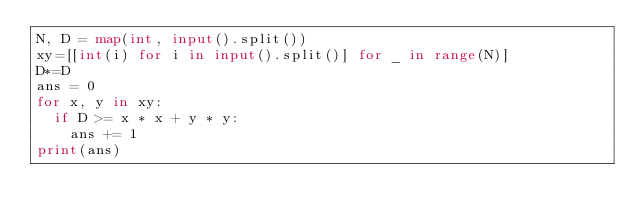Convert code to text. <code><loc_0><loc_0><loc_500><loc_500><_Python_>N, D = map(int, input().split())
xy=[[int(i) for i in input().split()] for _ in range(N)]
D*=D
ans = 0
for x, y in xy:
  if D >= x * x + y * y:
    ans += 1
print(ans)</code> 